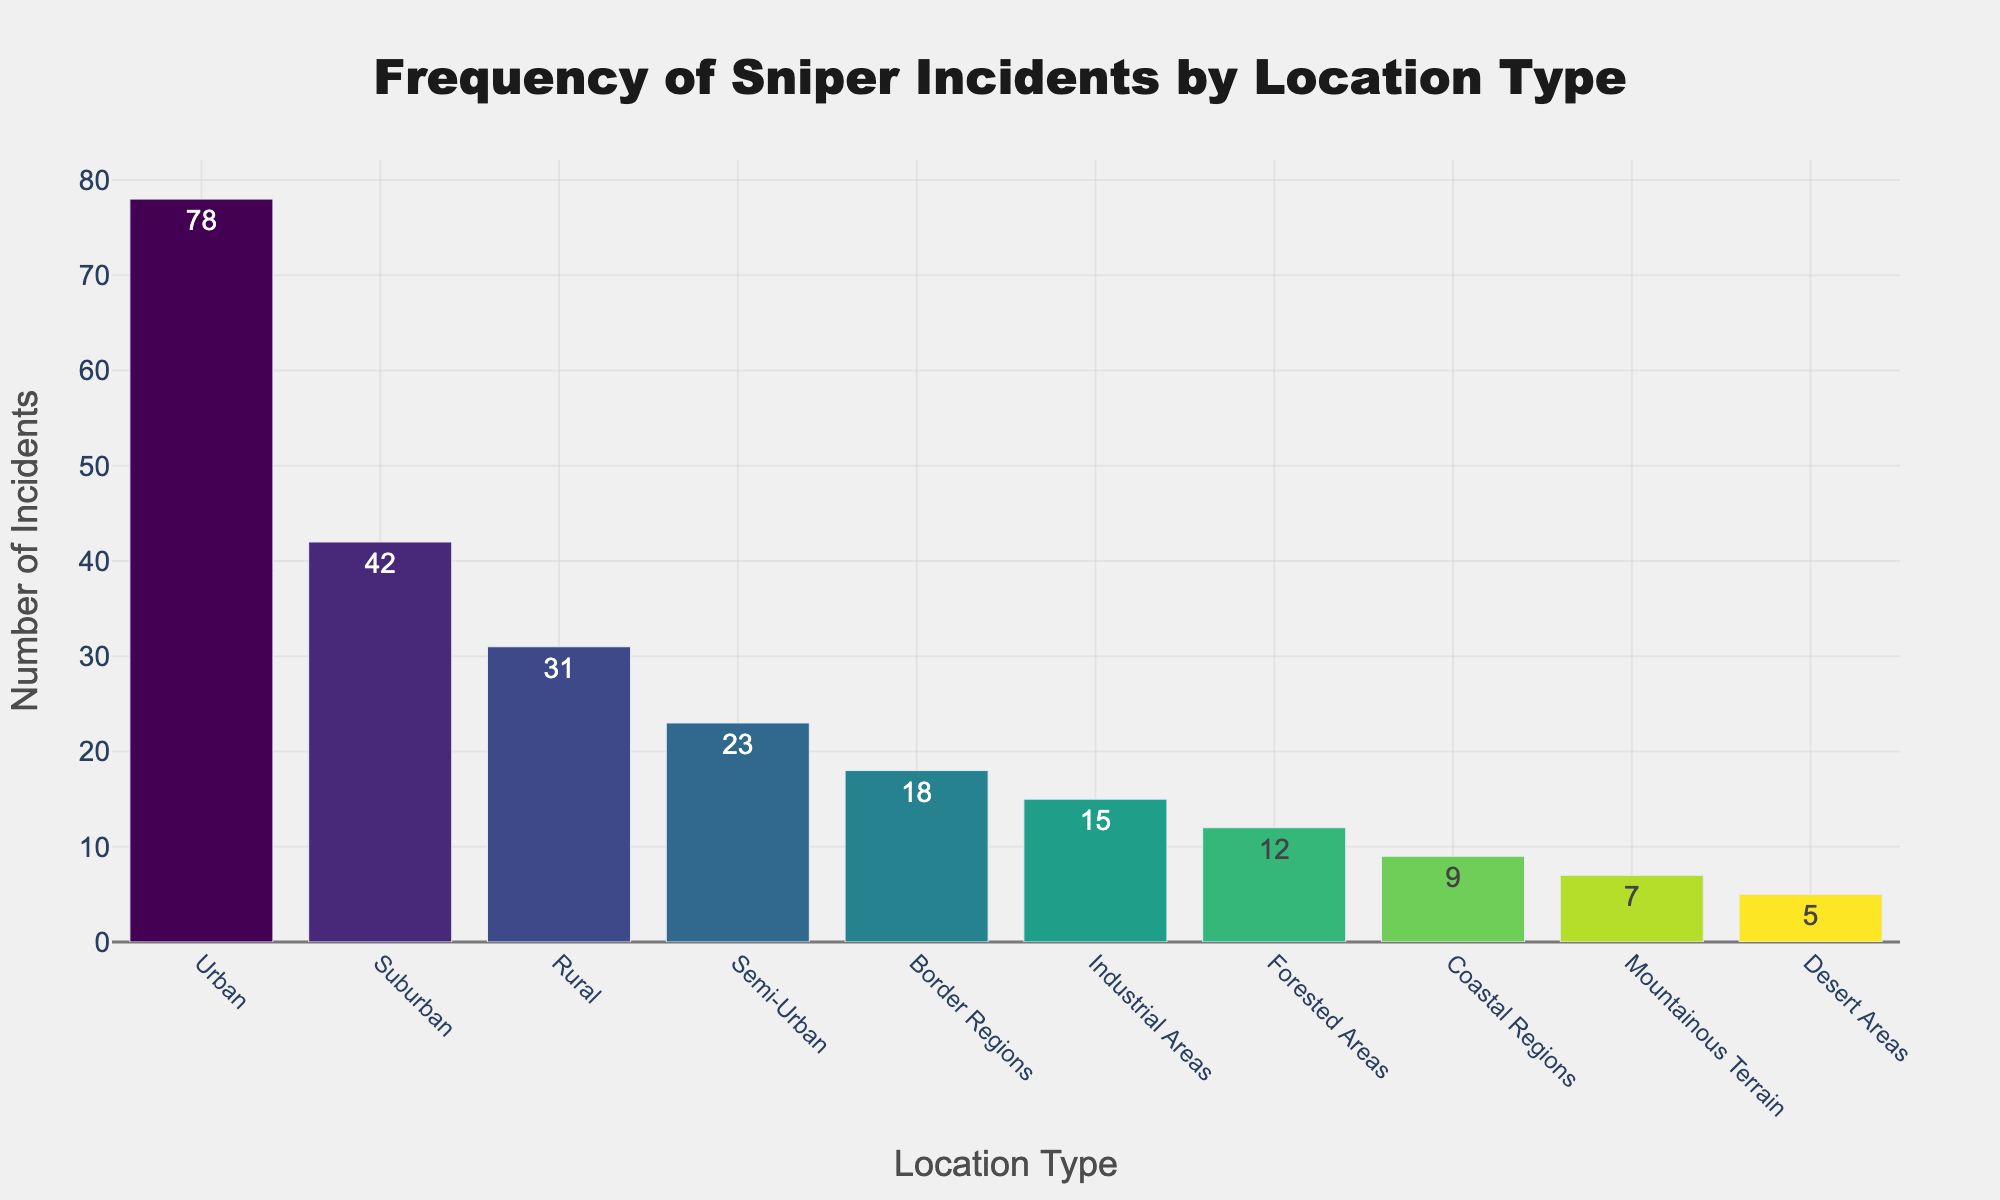What location type has the highest number of sniper incidents? By observing the bar chart, the tallest bar indicates the location type with the highest number of incidents, which is "Urban" with 78 incidents.
Answer: Urban How many total incidents occurred in rural and border regions combined? First, identify the number of incidents in "Rural" (31) and "Border Regions" (18) from the chart. Then, sum them up: 31 + 18 = 49.
Answer: 49 Which location type has more incidents: suburban or industrial areas? From the chart, "Suburban" has 42 incidents, and "Industrial Areas" has 15 incidents. Comparing these two values, suburban has more incidents.
Answer: Suburban What is the difference in the number of incidents between urban and rural areas? Identify the number of incidents in "Urban" (78) and "Rural" (31) from the chart. Then, calculate the difference: 78 - 31 = 47.
Answer: 47 Which location type has the second highest number of sniper incidents? Observing the chart, the second tallest bar corresponds to "Suburban," which has 42 incidents.
Answer: Suburban Among semi-urban, desert areas, and forested areas, which has the fewest incidents? From the chart, "Semi-Urban" has 23 incidents, "Desert Areas" has 5 incidents, and "Forested Areas" has 12 incidents. The fewest incidents are in "Desert Areas."
Answer: Desert Areas How many incidents occurred in the top three locations combined? The top three locations are "Urban" (78), "Suburban" (42), and "Rural" (31). Summing these: 78 + 42 + 31 = 151.
Answer: 151 What is the average number of incidents in coastal regions, mountainous terrain, and forested areas? From the chart, "Coastal Regions" has 9 incidents, "Mountainous Terrain" has 7, and "Forested Areas" has 12. Calculate the average: (9 + 7 + 12) / 3 = 28 / 3 ≈ 9.33.
Answer: 9.33 Are incidents in border regions greater than or less than those in semi-urban areas? The number of incidents in "Border Regions" is 18, and "Semi-Urban" is 23. Therefore, incidents in border regions are less than those in semi-urban areas.
Answer: Less What is the sum of incidents in industrial areas, coastal regions, and desert areas? From the chart, "Industrial Areas" has 15 incidents, "Coastal Regions" has 9, and "Desert Areas" has 5. Summing these: 15 + 9 + 5 = 29.
Answer: 29 